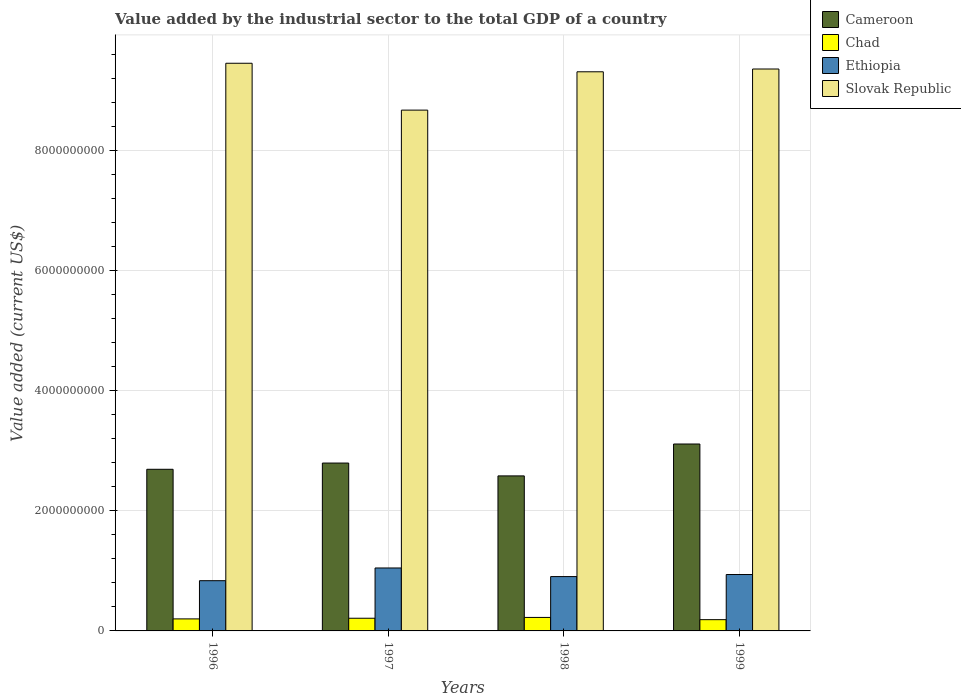How many groups of bars are there?
Ensure brevity in your answer.  4. How many bars are there on the 1st tick from the left?
Your answer should be very brief. 4. How many bars are there on the 2nd tick from the right?
Provide a succinct answer. 4. What is the label of the 2nd group of bars from the left?
Offer a terse response. 1997. In how many cases, is the number of bars for a given year not equal to the number of legend labels?
Your answer should be compact. 0. What is the value added by the industrial sector to the total GDP in Chad in 1996?
Make the answer very short. 2.00e+08. Across all years, what is the maximum value added by the industrial sector to the total GDP in Cameroon?
Provide a short and direct response. 3.11e+09. Across all years, what is the minimum value added by the industrial sector to the total GDP in Chad?
Give a very brief answer. 1.87e+08. In which year was the value added by the industrial sector to the total GDP in Ethiopia minimum?
Provide a succinct answer. 1996. What is the total value added by the industrial sector to the total GDP in Ethiopia in the graph?
Give a very brief answer. 3.73e+09. What is the difference between the value added by the industrial sector to the total GDP in Cameroon in 1997 and that in 1999?
Provide a short and direct response. -3.17e+08. What is the difference between the value added by the industrial sector to the total GDP in Cameroon in 1998 and the value added by the industrial sector to the total GDP in Chad in 1999?
Your response must be concise. 2.39e+09. What is the average value added by the industrial sector to the total GDP in Slovak Republic per year?
Your answer should be compact. 9.20e+09. In the year 1997, what is the difference between the value added by the industrial sector to the total GDP in Slovak Republic and value added by the industrial sector to the total GDP in Cameroon?
Provide a short and direct response. 5.88e+09. What is the ratio of the value added by the industrial sector to the total GDP in Slovak Republic in 1997 to that in 1999?
Your answer should be compact. 0.93. Is the difference between the value added by the industrial sector to the total GDP in Slovak Republic in 1997 and 1999 greater than the difference between the value added by the industrial sector to the total GDP in Cameroon in 1997 and 1999?
Offer a terse response. No. What is the difference between the highest and the second highest value added by the industrial sector to the total GDP in Ethiopia?
Ensure brevity in your answer.  1.09e+08. What is the difference between the highest and the lowest value added by the industrial sector to the total GDP in Ethiopia?
Provide a short and direct response. 2.12e+08. In how many years, is the value added by the industrial sector to the total GDP in Ethiopia greater than the average value added by the industrial sector to the total GDP in Ethiopia taken over all years?
Provide a succinct answer. 2. Is it the case that in every year, the sum of the value added by the industrial sector to the total GDP in Cameroon and value added by the industrial sector to the total GDP in Slovak Republic is greater than the sum of value added by the industrial sector to the total GDP in Chad and value added by the industrial sector to the total GDP in Ethiopia?
Provide a succinct answer. Yes. What does the 4th bar from the left in 1999 represents?
Provide a short and direct response. Slovak Republic. What does the 3rd bar from the right in 1997 represents?
Give a very brief answer. Chad. Is it the case that in every year, the sum of the value added by the industrial sector to the total GDP in Ethiopia and value added by the industrial sector to the total GDP in Cameroon is greater than the value added by the industrial sector to the total GDP in Chad?
Your response must be concise. Yes. What is the difference between two consecutive major ticks on the Y-axis?
Give a very brief answer. 2.00e+09. Does the graph contain any zero values?
Keep it short and to the point. No. Does the graph contain grids?
Make the answer very short. Yes. Where does the legend appear in the graph?
Offer a very short reply. Top right. How many legend labels are there?
Offer a very short reply. 4. How are the legend labels stacked?
Keep it short and to the point. Vertical. What is the title of the graph?
Provide a short and direct response. Value added by the industrial sector to the total GDP of a country. What is the label or title of the Y-axis?
Offer a very short reply. Value added (current US$). What is the Value added (current US$) of Cameroon in 1996?
Offer a terse response. 2.69e+09. What is the Value added (current US$) in Chad in 1996?
Your answer should be compact. 2.00e+08. What is the Value added (current US$) in Ethiopia in 1996?
Keep it short and to the point. 8.36e+08. What is the Value added (current US$) in Slovak Republic in 1996?
Make the answer very short. 9.45e+09. What is the Value added (current US$) in Cameroon in 1997?
Provide a short and direct response. 2.80e+09. What is the Value added (current US$) of Chad in 1997?
Offer a terse response. 2.11e+08. What is the Value added (current US$) of Ethiopia in 1997?
Make the answer very short. 1.05e+09. What is the Value added (current US$) in Slovak Republic in 1997?
Provide a succinct answer. 8.67e+09. What is the Value added (current US$) of Cameroon in 1998?
Provide a short and direct response. 2.58e+09. What is the Value added (current US$) of Chad in 1998?
Keep it short and to the point. 2.25e+08. What is the Value added (current US$) of Ethiopia in 1998?
Provide a succinct answer. 9.05e+08. What is the Value added (current US$) of Slovak Republic in 1998?
Your response must be concise. 9.31e+09. What is the Value added (current US$) of Cameroon in 1999?
Keep it short and to the point. 3.11e+09. What is the Value added (current US$) of Chad in 1999?
Give a very brief answer. 1.87e+08. What is the Value added (current US$) of Ethiopia in 1999?
Ensure brevity in your answer.  9.39e+08. What is the Value added (current US$) of Slovak Republic in 1999?
Ensure brevity in your answer.  9.36e+09. Across all years, what is the maximum Value added (current US$) of Cameroon?
Keep it short and to the point. 3.11e+09. Across all years, what is the maximum Value added (current US$) in Chad?
Provide a succinct answer. 2.25e+08. Across all years, what is the maximum Value added (current US$) in Ethiopia?
Ensure brevity in your answer.  1.05e+09. Across all years, what is the maximum Value added (current US$) of Slovak Republic?
Ensure brevity in your answer.  9.45e+09. Across all years, what is the minimum Value added (current US$) in Cameroon?
Offer a terse response. 2.58e+09. Across all years, what is the minimum Value added (current US$) of Chad?
Provide a short and direct response. 1.87e+08. Across all years, what is the minimum Value added (current US$) in Ethiopia?
Keep it short and to the point. 8.36e+08. Across all years, what is the minimum Value added (current US$) of Slovak Republic?
Offer a terse response. 8.67e+09. What is the total Value added (current US$) in Cameroon in the graph?
Provide a short and direct response. 1.12e+1. What is the total Value added (current US$) in Chad in the graph?
Your answer should be very brief. 8.23e+08. What is the total Value added (current US$) of Ethiopia in the graph?
Give a very brief answer. 3.73e+09. What is the total Value added (current US$) in Slovak Republic in the graph?
Make the answer very short. 3.68e+1. What is the difference between the Value added (current US$) in Cameroon in 1996 and that in 1997?
Keep it short and to the point. -1.04e+08. What is the difference between the Value added (current US$) of Chad in 1996 and that in 1997?
Offer a very short reply. -1.10e+07. What is the difference between the Value added (current US$) in Ethiopia in 1996 and that in 1997?
Your answer should be very brief. -2.12e+08. What is the difference between the Value added (current US$) in Slovak Republic in 1996 and that in 1997?
Your answer should be compact. 7.80e+08. What is the difference between the Value added (current US$) in Cameroon in 1996 and that in 1998?
Give a very brief answer. 1.10e+08. What is the difference between the Value added (current US$) in Chad in 1996 and that in 1998?
Make the answer very short. -2.45e+07. What is the difference between the Value added (current US$) of Ethiopia in 1996 and that in 1998?
Provide a succinct answer. -6.83e+07. What is the difference between the Value added (current US$) of Slovak Republic in 1996 and that in 1998?
Your answer should be very brief. 1.42e+08. What is the difference between the Value added (current US$) of Cameroon in 1996 and that in 1999?
Offer a terse response. -4.21e+08. What is the difference between the Value added (current US$) in Chad in 1996 and that in 1999?
Provide a short and direct response. 1.26e+07. What is the difference between the Value added (current US$) in Ethiopia in 1996 and that in 1999?
Your response must be concise. -1.03e+08. What is the difference between the Value added (current US$) in Slovak Republic in 1996 and that in 1999?
Make the answer very short. 9.57e+07. What is the difference between the Value added (current US$) in Cameroon in 1997 and that in 1998?
Make the answer very short. 2.14e+08. What is the difference between the Value added (current US$) of Chad in 1997 and that in 1998?
Your answer should be very brief. -1.35e+07. What is the difference between the Value added (current US$) of Ethiopia in 1997 and that in 1998?
Your answer should be very brief. 1.43e+08. What is the difference between the Value added (current US$) in Slovak Republic in 1997 and that in 1998?
Give a very brief answer. -6.38e+08. What is the difference between the Value added (current US$) in Cameroon in 1997 and that in 1999?
Your answer should be compact. -3.17e+08. What is the difference between the Value added (current US$) in Chad in 1997 and that in 1999?
Make the answer very short. 2.37e+07. What is the difference between the Value added (current US$) in Ethiopia in 1997 and that in 1999?
Offer a terse response. 1.09e+08. What is the difference between the Value added (current US$) in Slovak Republic in 1997 and that in 1999?
Provide a succinct answer. -6.85e+08. What is the difference between the Value added (current US$) of Cameroon in 1998 and that in 1999?
Offer a terse response. -5.31e+08. What is the difference between the Value added (current US$) in Chad in 1998 and that in 1999?
Provide a succinct answer. 3.71e+07. What is the difference between the Value added (current US$) in Ethiopia in 1998 and that in 1999?
Your response must be concise. -3.45e+07. What is the difference between the Value added (current US$) of Slovak Republic in 1998 and that in 1999?
Offer a terse response. -4.63e+07. What is the difference between the Value added (current US$) in Cameroon in 1996 and the Value added (current US$) in Chad in 1997?
Your answer should be very brief. 2.48e+09. What is the difference between the Value added (current US$) of Cameroon in 1996 and the Value added (current US$) of Ethiopia in 1997?
Your answer should be compact. 1.64e+09. What is the difference between the Value added (current US$) in Cameroon in 1996 and the Value added (current US$) in Slovak Republic in 1997?
Make the answer very short. -5.98e+09. What is the difference between the Value added (current US$) in Chad in 1996 and the Value added (current US$) in Ethiopia in 1997?
Give a very brief answer. -8.48e+08. What is the difference between the Value added (current US$) of Chad in 1996 and the Value added (current US$) of Slovak Republic in 1997?
Offer a terse response. -8.47e+09. What is the difference between the Value added (current US$) of Ethiopia in 1996 and the Value added (current US$) of Slovak Republic in 1997?
Your response must be concise. -7.84e+09. What is the difference between the Value added (current US$) of Cameroon in 1996 and the Value added (current US$) of Chad in 1998?
Provide a short and direct response. 2.47e+09. What is the difference between the Value added (current US$) of Cameroon in 1996 and the Value added (current US$) of Ethiopia in 1998?
Make the answer very short. 1.79e+09. What is the difference between the Value added (current US$) in Cameroon in 1996 and the Value added (current US$) in Slovak Republic in 1998?
Provide a short and direct response. -6.62e+09. What is the difference between the Value added (current US$) in Chad in 1996 and the Value added (current US$) in Ethiopia in 1998?
Ensure brevity in your answer.  -7.05e+08. What is the difference between the Value added (current US$) of Chad in 1996 and the Value added (current US$) of Slovak Republic in 1998?
Offer a very short reply. -9.11e+09. What is the difference between the Value added (current US$) of Ethiopia in 1996 and the Value added (current US$) of Slovak Republic in 1998?
Make the answer very short. -8.47e+09. What is the difference between the Value added (current US$) in Cameroon in 1996 and the Value added (current US$) in Chad in 1999?
Your answer should be very brief. 2.50e+09. What is the difference between the Value added (current US$) in Cameroon in 1996 and the Value added (current US$) in Ethiopia in 1999?
Your answer should be compact. 1.75e+09. What is the difference between the Value added (current US$) of Cameroon in 1996 and the Value added (current US$) of Slovak Republic in 1999?
Your response must be concise. -6.66e+09. What is the difference between the Value added (current US$) of Chad in 1996 and the Value added (current US$) of Ethiopia in 1999?
Offer a terse response. -7.39e+08. What is the difference between the Value added (current US$) in Chad in 1996 and the Value added (current US$) in Slovak Republic in 1999?
Your answer should be very brief. -9.16e+09. What is the difference between the Value added (current US$) in Ethiopia in 1996 and the Value added (current US$) in Slovak Republic in 1999?
Your answer should be very brief. -8.52e+09. What is the difference between the Value added (current US$) of Cameroon in 1997 and the Value added (current US$) of Chad in 1998?
Offer a terse response. 2.57e+09. What is the difference between the Value added (current US$) in Cameroon in 1997 and the Value added (current US$) in Ethiopia in 1998?
Ensure brevity in your answer.  1.89e+09. What is the difference between the Value added (current US$) in Cameroon in 1997 and the Value added (current US$) in Slovak Republic in 1998?
Ensure brevity in your answer.  -6.51e+09. What is the difference between the Value added (current US$) of Chad in 1997 and the Value added (current US$) of Ethiopia in 1998?
Keep it short and to the point. -6.93e+08. What is the difference between the Value added (current US$) of Chad in 1997 and the Value added (current US$) of Slovak Republic in 1998?
Your answer should be very brief. -9.10e+09. What is the difference between the Value added (current US$) of Ethiopia in 1997 and the Value added (current US$) of Slovak Republic in 1998?
Your answer should be compact. -8.26e+09. What is the difference between the Value added (current US$) in Cameroon in 1997 and the Value added (current US$) in Chad in 1999?
Ensure brevity in your answer.  2.61e+09. What is the difference between the Value added (current US$) of Cameroon in 1997 and the Value added (current US$) of Ethiopia in 1999?
Ensure brevity in your answer.  1.86e+09. What is the difference between the Value added (current US$) of Cameroon in 1997 and the Value added (current US$) of Slovak Republic in 1999?
Provide a short and direct response. -6.56e+09. What is the difference between the Value added (current US$) in Chad in 1997 and the Value added (current US$) in Ethiopia in 1999?
Give a very brief answer. -7.28e+08. What is the difference between the Value added (current US$) in Chad in 1997 and the Value added (current US$) in Slovak Republic in 1999?
Provide a succinct answer. -9.14e+09. What is the difference between the Value added (current US$) in Ethiopia in 1997 and the Value added (current US$) in Slovak Republic in 1999?
Keep it short and to the point. -8.31e+09. What is the difference between the Value added (current US$) in Cameroon in 1998 and the Value added (current US$) in Chad in 1999?
Give a very brief answer. 2.39e+09. What is the difference between the Value added (current US$) of Cameroon in 1998 and the Value added (current US$) of Ethiopia in 1999?
Your response must be concise. 1.64e+09. What is the difference between the Value added (current US$) in Cameroon in 1998 and the Value added (current US$) in Slovak Republic in 1999?
Give a very brief answer. -6.77e+09. What is the difference between the Value added (current US$) of Chad in 1998 and the Value added (current US$) of Ethiopia in 1999?
Provide a succinct answer. -7.15e+08. What is the difference between the Value added (current US$) in Chad in 1998 and the Value added (current US$) in Slovak Republic in 1999?
Offer a very short reply. -9.13e+09. What is the difference between the Value added (current US$) in Ethiopia in 1998 and the Value added (current US$) in Slovak Republic in 1999?
Ensure brevity in your answer.  -8.45e+09. What is the average Value added (current US$) of Cameroon per year?
Make the answer very short. 2.79e+09. What is the average Value added (current US$) of Chad per year?
Give a very brief answer. 2.06e+08. What is the average Value added (current US$) in Ethiopia per year?
Keep it short and to the point. 9.32e+08. What is the average Value added (current US$) in Slovak Republic per year?
Ensure brevity in your answer.  9.20e+09. In the year 1996, what is the difference between the Value added (current US$) of Cameroon and Value added (current US$) of Chad?
Provide a short and direct response. 2.49e+09. In the year 1996, what is the difference between the Value added (current US$) of Cameroon and Value added (current US$) of Ethiopia?
Your response must be concise. 1.85e+09. In the year 1996, what is the difference between the Value added (current US$) of Cameroon and Value added (current US$) of Slovak Republic?
Your answer should be compact. -6.76e+09. In the year 1996, what is the difference between the Value added (current US$) in Chad and Value added (current US$) in Ethiopia?
Your answer should be compact. -6.36e+08. In the year 1996, what is the difference between the Value added (current US$) of Chad and Value added (current US$) of Slovak Republic?
Keep it short and to the point. -9.25e+09. In the year 1996, what is the difference between the Value added (current US$) in Ethiopia and Value added (current US$) in Slovak Republic?
Your response must be concise. -8.62e+09. In the year 1997, what is the difference between the Value added (current US$) in Cameroon and Value added (current US$) in Chad?
Keep it short and to the point. 2.58e+09. In the year 1997, what is the difference between the Value added (current US$) of Cameroon and Value added (current US$) of Ethiopia?
Your answer should be very brief. 1.75e+09. In the year 1997, what is the difference between the Value added (current US$) in Cameroon and Value added (current US$) in Slovak Republic?
Ensure brevity in your answer.  -5.88e+09. In the year 1997, what is the difference between the Value added (current US$) of Chad and Value added (current US$) of Ethiopia?
Offer a terse response. -8.37e+08. In the year 1997, what is the difference between the Value added (current US$) of Chad and Value added (current US$) of Slovak Republic?
Make the answer very short. -8.46e+09. In the year 1997, what is the difference between the Value added (current US$) in Ethiopia and Value added (current US$) in Slovak Republic?
Ensure brevity in your answer.  -7.62e+09. In the year 1998, what is the difference between the Value added (current US$) in Cameroon and Value added (current US$) in Chad?
Your answer should be compact. 2.36e+09. In the year 1998, what is the difference between the Value added (current US$) in Cameroon and Value added (current US$) in Ethiopia?
Offer a terse response. 1.68e+09. In the year 1998, what is the difference between the Value added (current US$) in Cameroon and Value added (current US$) in Slovak Republic?
Give a very brief answer. -6.73e+09. In the year 1998, what is the difference between the Value added (current US$) of Chad and Value added (current US$) of Ethiopia?
Give a very brief answer. -6.80e+08. In the year 1998, what is the difference between the Value added (current US$) of Chad and Value added (current US$) of Slovak Republic?
Offer a very short reply. -9.09e+09. In the year 1998, what is the difference between the Value added (current US$) in Ethiopia and Value added (current US$) in Slovak Republic?
Offer a terse response. -8.41e+09. In the year 1999, what is the difference between the Value added (current US$) of Cameroon and Value added (current US$) of Chad?
Your answer should be compact. 2.92e+09. In the year 1999, what is the difference between the Value added (current US$) in Cameroon and Value added (current US$) in Ethiopia?
Ensure brevity in your answer.  2.17e+09. In the year 1999, what is the difference between the Value added (current US$) in Cameroon and Value added (current US$) in Slovak Republic?
Offer a very short reply. -6.24e+09. In the year 1999, what is the difference between the Value added (current US$) of Chad and Value added (current US$) of Ethiopia?
Your answer should be compact. -7.52e+08. In the year 1999, what is the difference between the Value added (current US$) of Chad and Value added (current US$) of Slovak Republic?
Give a very brief answer. -9.17e+09. In the year 1999, what is the difference between the Value added (current US$) of Ethiopia and Value added (current US$) of Slovak Republic?
Make the answer very short. -8.42e+09. What is the ratio of the Value added (current US$) in Cameroon in 1996 to that in 1997?
Ensure brevity in your answer.  0.96. What is the ratio of the Value added (current US$) of Chad in 1996 to that in 1997?
Your answer should be compact. 0.95. What is the ratio of the Value added (current US$) in Ethiopia in 1996 to that in 1997?
Offer a terse response. 0.8. What is the ratio of the Value added (current US$) in Slovak Republic in 1996 to that in 1997?
Give a very brief answer. 1.09. What is the ratio of the Value added (current US$) in Cameroon in 1996 to that in 1998?
Give a very brief answer. 1.04. What is the ratio of the Value added (current US$) in Chad in 1996 to that in 1998?
Your response must be concise. 0.89. What is the ratio of the Value added (current US$) of Ethiopia in 1996 to that in 1998?
Make the answer very short. 0.92. What is the ratio of the Value added (current US$) in Slovak Republic in 1996 to that in 1998?
Keep it short and to the point. 1.02. What is the ratio of the Value added (current US$) in Cameroon in 1996 to that in 1999?
Provide a short and direct response. 0.86. What is the ratio of the Value added (current US$) in Chad in 1996 to that in 1999?
Ensure brevity in your answer.  1.07. What is the ratio of the Value added (current US$) in Ethiopia in 1996 to that in 1999?
Offer a very short reply. 0.89. What is the ratio of the Value added (current US$) of Slovak Republic in 1996 to that in 1999?
Offer a very short reply. 1.01. What is the ratio of the Value added (current US$) of Cameroon in 1997 to that in 1998?
Ensure brevity in your answer.  1.08. What is the ratio of the Value added (current US$) of Chad in 1997 to that in 1998?
Ensure brevity in your answer.  0.94. What is the ratio of the Value added (current US$) of Ethiopia in 1997 to that in 1998?
Give a very brief answer. 1.16. What is the ratio of the Value added (current US$) of Slovak Republic in 1997 to that in 1998?
Your answer should be very brief. 0.93. What is the ratio of the Value added (current US$) of Cameroon in 1997 to that in 1999?
Your answer should be very brief. 0.9. What is the ratio of the Value added (current US$) of Chad in 1997 to that in 1999?
Ensure brevity in your answer.  1.13. What is the ratio of the Value added (current US$) in Ethiopia in 1997 to that in 1999?
Ensure brevity in your answer.  1.12. What is the ratio of the Value added (current US$) in Slovak Republic in 1997 to that in 1999?
Offer a very short reply. 0.93. What is the ratio of the Value added (current US$) in Cameroon in 1998 to that in 1999?
Offer a very short reply. 0.83. What is the ratio of the Value added (current US$) of Chad in 1998 to that in 1999?
Ensure brevity in your answer.  1.2. What is the ratio of the Value added (current US$) in Ethiopia in 1998 to that in 1999?
Your answer should be very brief. 0.96. What is the ratio of the Value added (current US$) in Slovak Republic in 1998 to that in 1999?
Give a very brief answer. 1. What is the difference between the highest and the second highest Value added (current US$) in Cameroon?
Ensure brevity in your answer.  3.17e+08. What is the difference between the highest and the second highest Value added (current US$) of Chad?
Your answer should be compact. 1.35e+07. What is the difference between the highest and the second highest Value added (current US$) of Ethiopia?
Offer a very short reply. 1.09e+08. What is the difference between the highest and the second highest Value added (current US$) of Slovak Republic?
Provide a short and direct response. 9.57e+07. What is the difference between the highest and the lowest Value added (current US$) in Cameroon?
Keep it short and to the point. 5.31e+08. What is the difference between the highest and the lowest Value added (current US$) in Chad?
Provide a short and direct response. 3.71e+07. What is the difference between the highest and the lowest Value added (current US$) in Ethiopia?
Ensure brevity in your answer.  2.12e+08. What is the difference between the highest and the lowest Value added (current US$) in Slovak Republic?
Keep it short and to the point. 7.80e+08. 